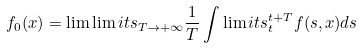Convert formula to latex. <formula><loc_0><loc_0><loc_500><loc_500>f _ { 0 } ( x ) = \lim \lim i t s _ { T \to + \infty } \frac { 1 } { T } \int \lim i t s _ { t } ^ { t + T } f ( s , x ) d s</formula> 